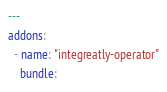Convert code to text. <code><loc_0><loc_0><loc_500><loc_500><_YAML_>---
addons:
  - name: "integreatly-operator"
    bundle:</code> 